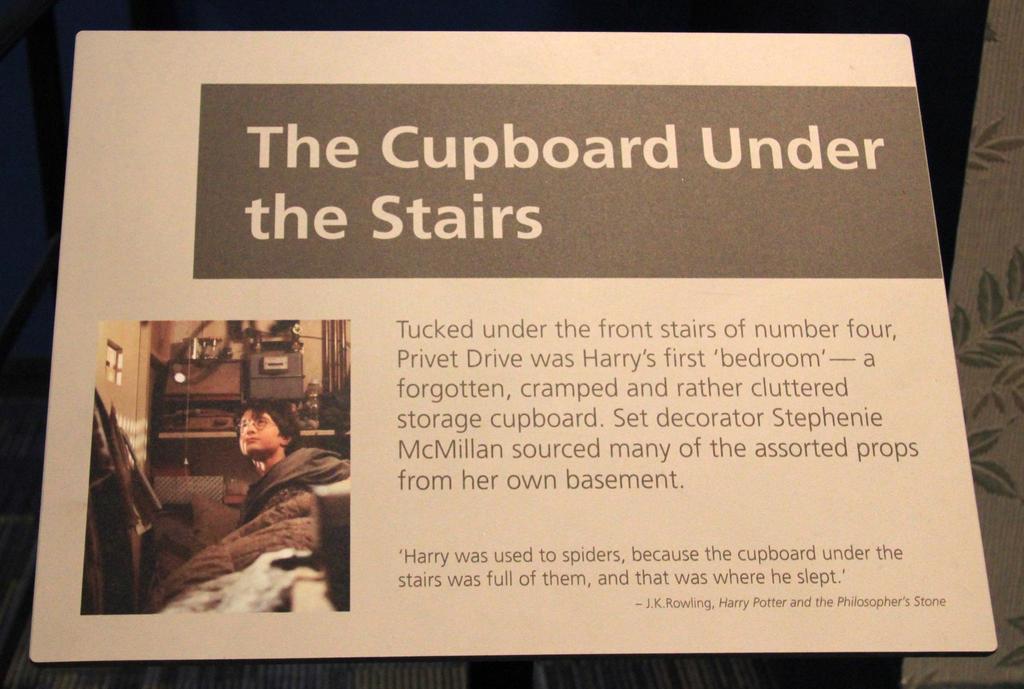What is the title of this?
Provide a succinct answer. The cupboard under the stairs. 